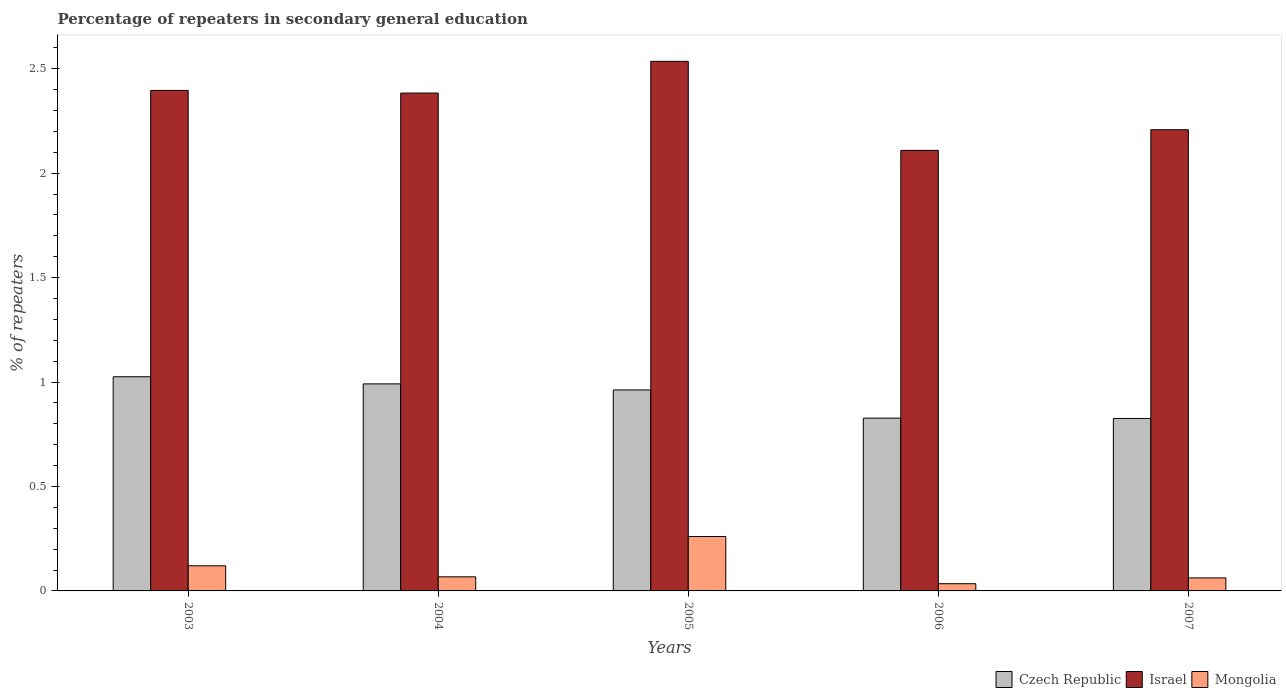How many groups of bars are there?
Offer a terse response. 5. Are the number of bars per tick equal to the number of legend labels?
Offer a terse response. Yes. What is the label of the 2nd group of bars from the left?
Ensure brevity in your answer.  2004. In how many cases, is the number of bars for a given year not equal to the number of legend labels?
Your answer should be very brief. 0. What is the percentage of repeaters in secondary general education in Israel in 2007?
Your answer should be compact. 2.21. Across all years, what is the maximum percentage of repeaters in secondary general education in Czech Republic?
Make the answer very short. 1.03. Across all years, what is the minimum percentage of repeaters in secondary general education in Israel?
Your answer should be compact. 2.11. In which year was the percentage of repeaters in secondary general education in Czech Republic minimum?
Ensure brevity in your answer.  2007. What is the total percentage of repeaters in secondary general education in Czech Republic in the graph?
Keep it short and to the point. 4.63. What is the difference between the percentage of repeaters in secondary general education in Czech Republic in 2003 and that in 2004?
Your answer should be very brief. 0.03. What is the difference between the percentage of repeaters in secondary general education in Israel in 2003 and the percentage of repeaters in secondary general education in Mongolia in 2004?
Your answer should be very brief. 2.33. What is the average percentage of repeaters in secondary general education in Mongolia per year?
Provide a succinct answer. 0.11. In the year 2007, what is the difference between the percentage of repeaters in secondary general education in Israel and percentage of repeaters in secondary general education in Czech Republic?
Provide a short and direct response. 1.38. In how many years, is the percentage of repeaters in secondary general education in Mongolia greater than 1.1 %?
Offer a terse response. 0. What is the ratio of the percentage of repeaters in secondary general education in Mongolia in 2003 to that in 2006?
Provide a short and direct response. 3.49. Is the percentage of repeaters in secondary general education in Mongolia in 2003 less than that in 2006?
Make the answer very short. No. What is the difference between the highest and the second highest percentage of repeaters in secondary general education in Israel?
Offer a terse response. 0.14. What is the difference between the highest and the lowest percentage of repeaters in secondary general education in Israel?
Ensure brevity in your answer.  0.43. In how many years, is the percentage of repeaters in secondary general education in Mongolia greater than the average percentage of repeaters in secondary general education in Mongolia taken over all years?
Your response must be concise. 2. What does the 3rd bar from the right in 2007 represents?
Give a very brief answer. Czech Republic. How many bars are there?
Keep it short and to the point. 15. What is the difference between two consecutive major ticks on the Y-axis?
Provide a short and direct response. 0.5. How many legend labels are there?
Ensure brevity in your answer.  3. What is the title of the graph?
Ensure brevity in your answer.  Percentage of repeaters in secondary general education. Does "Oman" appear as one of the legend labels in the graph?
Your answer should be compact. No. What is the label or title of the X-axis?
Your answer should be compact. Years. What is the label or title of the Y-axis?
Make the answer very short. % of repeaters. What is the % of repeaters of Czech Republic in 2003?
Provide a succinct answer. 1.03. What is the % of repeaters of Israel in 2003?
Provide a short and direct response. 2.4. What is the % of repeaters of Mongolia in 2003?
Your answer should be compact. 0.12. What is the % of repeaters of Czech Republic in 2004?
Give a very brief answer. 0.99. What is the % of repeaters of Israel in 2004?
Provide a succinct answer. 2.38. What is the % of repeaters of Mongolia in 2004?
Give a very brief answer. 0.07. What is the % of repeaters in Czech Republic in 2005?
Ensure brevity in your answer.  0.96. What is the % of repeaters in Israel in 2005?
Provide a short and direct response. 2.53. What is the % of repeaters in Mongolia in 2005?
Make the answer very short. 0.26. What is the % of repeaters in Czech Republic in 2006?
Provide a succinct answer. 0.83. What is the % of repeaters in Israel in 2006?
Your answer should be compact. 2.11. What is the % of repeaters in Mongolia in 2006?
Make the answer very short. 0.03. What is the % of repeaters of Czech Republic in 2007?
Provide a succinct answer. 0.83. What is the % of repeaters in Israel in 2007?
Give a very brief answer. 2.21. What is the % of repeaters in Mongolia in 2007?
Your answer should be compact. 0.06. Across all years, what is the maximum % of repeaters in Czech Republic?
Your answer should be compact. 1.03. Across all years, what is the maximum % of repeaters in Israel?
Your response must be concise. 2.53. Across all years, what is the maximum % of repeaters in Mongolia?
Your response must be concise. 0.26. Across all years, what is the minimum % of repeaters of Czech Republic?
Your answer should be very brief. 0.83. Across all years, what is the minimum % of repeaters of Israel?
Your response must be concise. 2.11. Across all years, what is the minimum % of repeaters of Mongolia?
Make the answer very short. 0.03. What is the total % of repeaters in Czech Republic in the graph?
Ensure brevity in your answer.  4.63. What is the total % of repeaters of Israel in the graph?
Your answer should be very brief. 11.63. What is the total % of repeaters of Mongolia in the graph?
Your answer should be compact. 0.55. What is the difference between the % of repeaters in Czech Republic in 2003 and that in 2004?
Ensure brevity in your answer.  0.03. What is the difference between the % of repeaters in Israel in 2003 and that in 2004?
Keep it short and to the point. 0.01. What is the difference between the % of repeaters of Mongolia in 2003 and that in 2004?
Make the answer very short. 0.05. What is the difference between the % of repeaters of Czech Republic in 2003 and that in 2005?
Your answer should be compact. 0.06. What is the difference between the % of repeaters in Israel in 2003 and that in 2005?
Your answer should be very brief. -0.14. What is the difference between the % of repeaters of Mongolia in 2003 and that in 2005?
Provide a short and direct response. -0.14. What is the difference between the % of repeaters of Czech Republic in 2003 and that in 2006?
Your answer should be compact. 0.2. What is the difference between the % of repeaters of Israel in 2003 and that in 2006?
Your answer should be very brief. 0.29. What is the difference between the % of repeaters in Mongolia in 2003 and that in 2006?
Make the answer very short. 0.09. What is the difference between the % of repeaters in Czech Republic in 2003 and that in 2007?
Give a very brief answer. 0.2. What is the difference between the % of repeaters in Israel in 2003 and that in 2007?
Give a very brief answer. 0.19. What is the difference between the % of repeaters in Mongolia in 2003 and that in 2007?
Provide a short and direct response. 0.06. What is the difference between the % of repeaters in Czech Republic in 2004 and that in 2005?
Make the answer very short. 0.03. What is the difference between the % of repeaters of Israel in 2004 and that in 2005?
Your answer should be very brief. -0.15. What is the difference between the % of repeaters of Mongolia in 2004 and that in 2005?
Your answer should be compact. -0.19. What is the difference between the % of repeaters in Czech Republic in 2004 and that in 2006?
Provide a short and direct response. 0.16. What is the difference between the % of repeaters in Israel in 2004 and that in 2006?
Provide a short and direct response. 0.27. What is the difference between the % of repeaters in Mongolia in 2004 and that in 2006?
Provide a succinct answer. 0.03. What is the difference between the % of repeaters in Czech Republic in 2004 and that in 2007?
Your answer should be very brief. 0.17. What is the difference between the % of repeaters of Israel in 2004 and that in 2007?
Offer a very short reply. 0.18. What is the difference between the % of repeaters in Mongolia in 2004 and that in 2007?
Make the answer very short. 0.01. What is the difference between the % of repeaters of Czech Republic in 2005 and that in 2006?
Your response must be concise. 0.13. What is the difference between the % of repeaters in Israel in 2005 and that in 2006?
Make the answer very short. 0.43. What is the difference between the % of repeaters in Mongolia in 2005 and that in 2006?
Keep it short and to the point. 0.23. What is the difference between the % of repeaters of Czech Republic in 2005 and that in 2007?
Offer a terse response. 0.14. What is the difference between the % of repeaters of Israel in 2005 and that in 2007?
Offer a terse response. 0.33. What is the difference between the % of repeaters in Mongolia in 2005 and that in 2007?
Provide a succinct answer. 0.2. What is the difference between the % of repeaters of Czech Republic in 2006 and that in 2007?
Your answer should be very brief. 0. What is the difference between the % of repeaters in Israel in 2006 and that in 2007?
Give a very brief answer. -0.1. What is the difference between the % of repeaters in Mongolia in 2006 and that in 2007?
Keep it short and to the point. -0.03. What is the difference between the % of repeaters of Czech Republic in 2003 and the % of repeaters of Israel in 2004?
Your answer should be compact. -1.36. What is the difference between the % of repeaters of Czech Republic in 2003 and the % of repeaters of Mongolia in 2004?
Ensure brevity in your answer.  0.96. What is the difference between the % of repeaters in Israel in 2003 and the % of repeaters in Mongolia in 2004?
Provide a short and direct response. 2.33. What is the difference between the % of repeaters in Czech Republic in 2003 and the % of repeaters in Israel in 2005?
Your response must be concise. -1.51. What is the difference between the % of repeaters of Czech Republic in 2003 and the % of repeaters of Mongolia in 2005?
Offer a terse response. 0.76. What is the difference between the % of repeaters of Israel in 2003 and the % of repeaters of Mongolia in 2005?
Give a very brief answer. 2.14. What is the difference between the % of repeaters of Czech Republic in 2003 and the % of repeaters of Israel in 2006?
Provide a short and direct response. -1.08. What is the difference between the % of repeaters in Czech Republic in 2003 and the % of repeaters in Mongolia in 2006?
Keep it short and to the point. 0.99. What is the difference between the % of repeaters in Israel in 2003 and the % of repeaters in Mongolia in 2006?
Offer a terse response. 2.36. What is the difference between the % of repeaters in Czech Republic in 2003 and the % of repeaters in Israel in 2007?
Your answer should be very brief. -1.18. What is the difference between the % of repeaters in Czech Republic in 2003 and the % of repeaters in Mongolia in 2007?
Offer a very short reply. 0.96. What is the difference between the % of repeaters of Israel in 2003 and the % of repeaters of Mongolia in 2007?
Provide a succinct answer. 2.33. What is the difference between the % of repeaters in Czech Republic in 2004 and the % of repeaters in Israel in 2005?
Give a very brief answer. -1.54. What is the difference between the % of repeaters in Czech Republic in 2004 and the % of repeaters in Mongolia in 2005?
Ensure brevity in your answer.  0.73. What is the difference between the % of repeaters in Israel in 2004 and the % of repeaters in Mongolia in 2005?
Keep it short and to the point. 2.12. What is the difference between the % of repeaters in Czech Republic in 2004 and the % of repeaters in Israel in 2006?
Give a very brief answer. -1.12. What is the difference between the % of repeaters of Czech Republic in 2004 and the % of repeaters of Mongolia in 2006?
Ensure brevity in your answer.  0.96. What is the difference between the % of repeaters in Israel in 2004 and the % of repeaters in Mongolia in 2006?
Make the answer very short. 2.35. What is the difference between the % of repeaters in Czech Republic in 2004 and the % of repeaters in Israel in 2007?
Make the answer very short. -1.22. What is the difference between the % of repeaters in Czech Republic in 2004 and the % of repeaters in Mongolia in 2007?
Ensure brevity in your answer.  0.93. What is the difference between the % of repeaters in Israel in 2004 and the % of repeaters in Mongolia in 2007?
Offer a very short reply. 2.32. What is the difference between the % of repeaters in Czech Republic in 2005 and the % of repeaters in Israel in 2006?
Offer a very short reply. -1.15. What is the difference between the % of repeaters in Czech Republic in 2005 and the % of repeaters in Mongolia in 2006?
Offer a very short reply. 0.93. What is the difference between the % of repeaters in Israel in 2005 and the % of repeaters in Mongolia in 2006?
Your answer should be compact. 2.5. What is the difference between the % of repeaters of Czech Republic in 2005 and the % of repeaters of Israel in 2007?
Offer a very short reply. -1.25. What is the difference between the % of repeaters of Czech Republic in 2005 and the % of repeaters of Mongolia in 2007?
Provide a succinct answer. 0.9. What is the difference between the % of repeaters in Israel in 2005 and the % of repeaters in Mongolia in 2007?
Ensure brevity in your answer.  2.47. What is the difference between the % of repeaters in Czech Republic in 2006 and the % of repeaters in Israel in 2007?
Your answer should be very brief. -1.38. What is the difference between the % of repeaters of Czech Republic in 2006 and the % of repeaters of Mongolia in 2007?
Keep it short and to the point. 0.76. What is the difference between the % of repeaters of Israel in 2006 and the % of repeaters of Mongolia in 2007?
Your answer should be very brief. 2.05. What is the average % of repeaters of Czech Republic per year?
Make the answer very short. 0.93. What is the average % of repeaters of Israel per year?
Ensure brevity in your answer.  2.33. What is the average % of repeaters of Mongolia per year?
Your answer should be compact. 0.11. In the year 2003, what is the difference between the % of repeaters in Czech Republic and % of repeaters in Israel?
Give a very brief answer. -1.37. In the year 2003, what is the difference between the % of repeaters in Czech Republic and % of repeaters in Mongolia?
Provide a succinct answer. 0.9. In the year 2003, what is the difference between the % of repeaters of Israel and % of repeaters of Mongolia?
Keep it short and to the point. 2.28. In the year 2004, what is the difference between the % of repeaters of Czech Republic and % of repeaters of Israel?
Your answer should be compact. -1.39. In the year 2004, what is the difference between the % of repeaters of Czech Republic and % of repeaters of Mongolia?
Keep it short and to the point. 0.92. In the year 2004, what is the difference between the % of repeaters of Israel and % of repeaters of Mongolia?
Your answer should be compact. 2.32. In the year 2005, what is the difference between the % of repeaters in Czech Republic and % of repeaters in Israel?
Your response must be concise. -1.57. In the year 2005, what is the difference between the % of repeaters of Czech Republic and % of repeaters of Mongolia?
Give a very brief answer. 0.7. In the year 2005, what is the difference between the % of repeaters of Israel and % of repeaters of Mongolia?
Keep it short and to the point. 2.27. In the year 2006, what is the difference between the % of repeaters of Czech Republic and % of repeaters of Israel?
Your response must be concise. -1.28. In the year 2006, what is the difference between the % of repeaters in Czech Republic and % of repeaters in Mongolia?
Offer a very short reply. 0.79. In the year 2006, what is the difference between the % of repeaters of Israel and % of repeaters of Mongolia?
Provide a short and direct response. 2.07. In the year 2007, what is the difference between the % of repeaters in Czech Republic and % of repeaters in Israel?
Ensure brevity in your answer.  -1.38. In the year 2007, what is the difference between the % of repeaters of Czech Republic and % of repeaters of Mongolia?
Provide a succinct answer. 0.76. In the year 2007, what is the difference between the % of repeaters in Israel and % of repeaters in Mongolia?
Offer a terse response. 2.15. What is the ratio of the % of repeaters of Czech Republic in 2003 to that in 2004?
Offer a very short reply. 1.03. What is the ratio of the % of repeaters in Mongolia in 2003 to that in 2004?
Provide a succinct answer. 1.78. What is the ratio of the % of repeaters in Czech Republic in 2003 to that in 2005?
Offer a terse response. 1.07. What is the ratio of the % of repeaters of Israel in 2003 to that in 2005?
Ensure brevity in your answer.  0.95. What is the ratio of the % of repeaters of Mongolia in 2003 to that in 2005?
Keep it short and to the point. 0.46. What is the ratio of the % of repeaters in Czech Republic in 2003 to that in 2006?
Ensure brevity in your answer.  1.24. What is the ratio of the % of repeaters in Israel in 2003 to that in 2006?
Your response must be concise. 1.14. What is the ratio of the % of repeaters of Mongolia in 2003 to that in 2006?
Make the answer very short. 3.49. What is the ratio of the % of repeaters of Czech Republic in 2003 to that in 2007?
Give a very brief answer. 1.24. What is the ratio of the % of repeaters in Israel in 2003 to that in 2007?
Provide a succinct answer. 1.09. What is the ratio of the % of repeaters in Mongolia in 2003 to that in 2007?
Give a very brief answer. 1.93. What is the ratio of the % of repeaters of Czech Republic in 2004 to that in 2005?
Provide a succinct answer. 1.03. What is the ratio of the % of repeaters in Israel in 2004 to that in 2005?
Offer a very short reply. 0.94. What is the ratio of the % of repeaters of Mongolia in 2004 to that in 2005?
Offer a very short reply. 0.26. What is the ratio of the % of repeaters of Czech Republic in 2004 to that in 2006?
Give a very brief answer. 1.2. What is the ratio of the % of repeaters of Israel in 2004 to that in 2006?
Offer a terse response. 1.13. What is the ratio of the % of repeaters in Mongolia in 2004 to that in 2006?
Keep it short and to the point. 1.96. What is the ratio of the % of repeaters in Czech Republic in 2004 to that in 2007?
Make the answer very short. 1.2. What is the ratio of the % of repeaters in Israel in 2004 to that in 2007?
Keep it short and to the point. 1.08. What is the ratio of the % of repeaters in Mongolia in 2004 to that in 2007?
Give a very brief answer. 1.08. What is the ratio of the % of repeaters of Czech Republic in 2005 to that in 2006?
Ensure brevity in your answer.  1.16. What is the ratio of the % of repeaters of Israel in 2005 to that in 2006?
Keep it short and to the point. 1.2. What is the ratio of the % of repeaters in Mongolia in 2005 to that in 2006?
Make the answer very short. 7.55. What is the ratio of the % of repeaters of Czech Republic in 2005 to that in 2007?
Provide a short and direct response. 1.17. What is the ratio of the % of repeaters of Israel in 2005 to that in 2007?
Ensure brevity in your answer.  1.15. What is the ratio of the % of repeaters of Mongolia in 2005 to that in 2007?
Provide a short and direct response. 4.18. What is the ratio of the % of repeaters of Czech Republic in 2006 to that in 2007?
Offer a terse response. 1. What is the ratio of the % of repeaters of Israel in 2006 to that in 2007?
Give a very brief answer. 0.96. What is the ratio of the % of repeaters of Mongolia in 2006 to that in 2007?
Your answer should be very brief. 0.55. What is the difference between the highest and the second highest % of repeaters in Czech Republic?
Give a very brief answer. 0.03. What is the difference between the highest and the second highest % of repeaters in Israel?
Your response must be concise. 0.14. What is the difference between the highest and the second highest % of repeaters of Mongolia?
Your answer should be compact. 0.14. What is the difference between the highest and the lowest % of repeaters in Czech Republic?
Keep it short and to the point. 0.2. What is the difference between the highest and the lowest % of repeaters of Israel?
Provide a succinct answer. 0.43. What is the difference between the highest and the lowest % of repeaters in Mongolia?
Your answer should be compact. 0.23. 